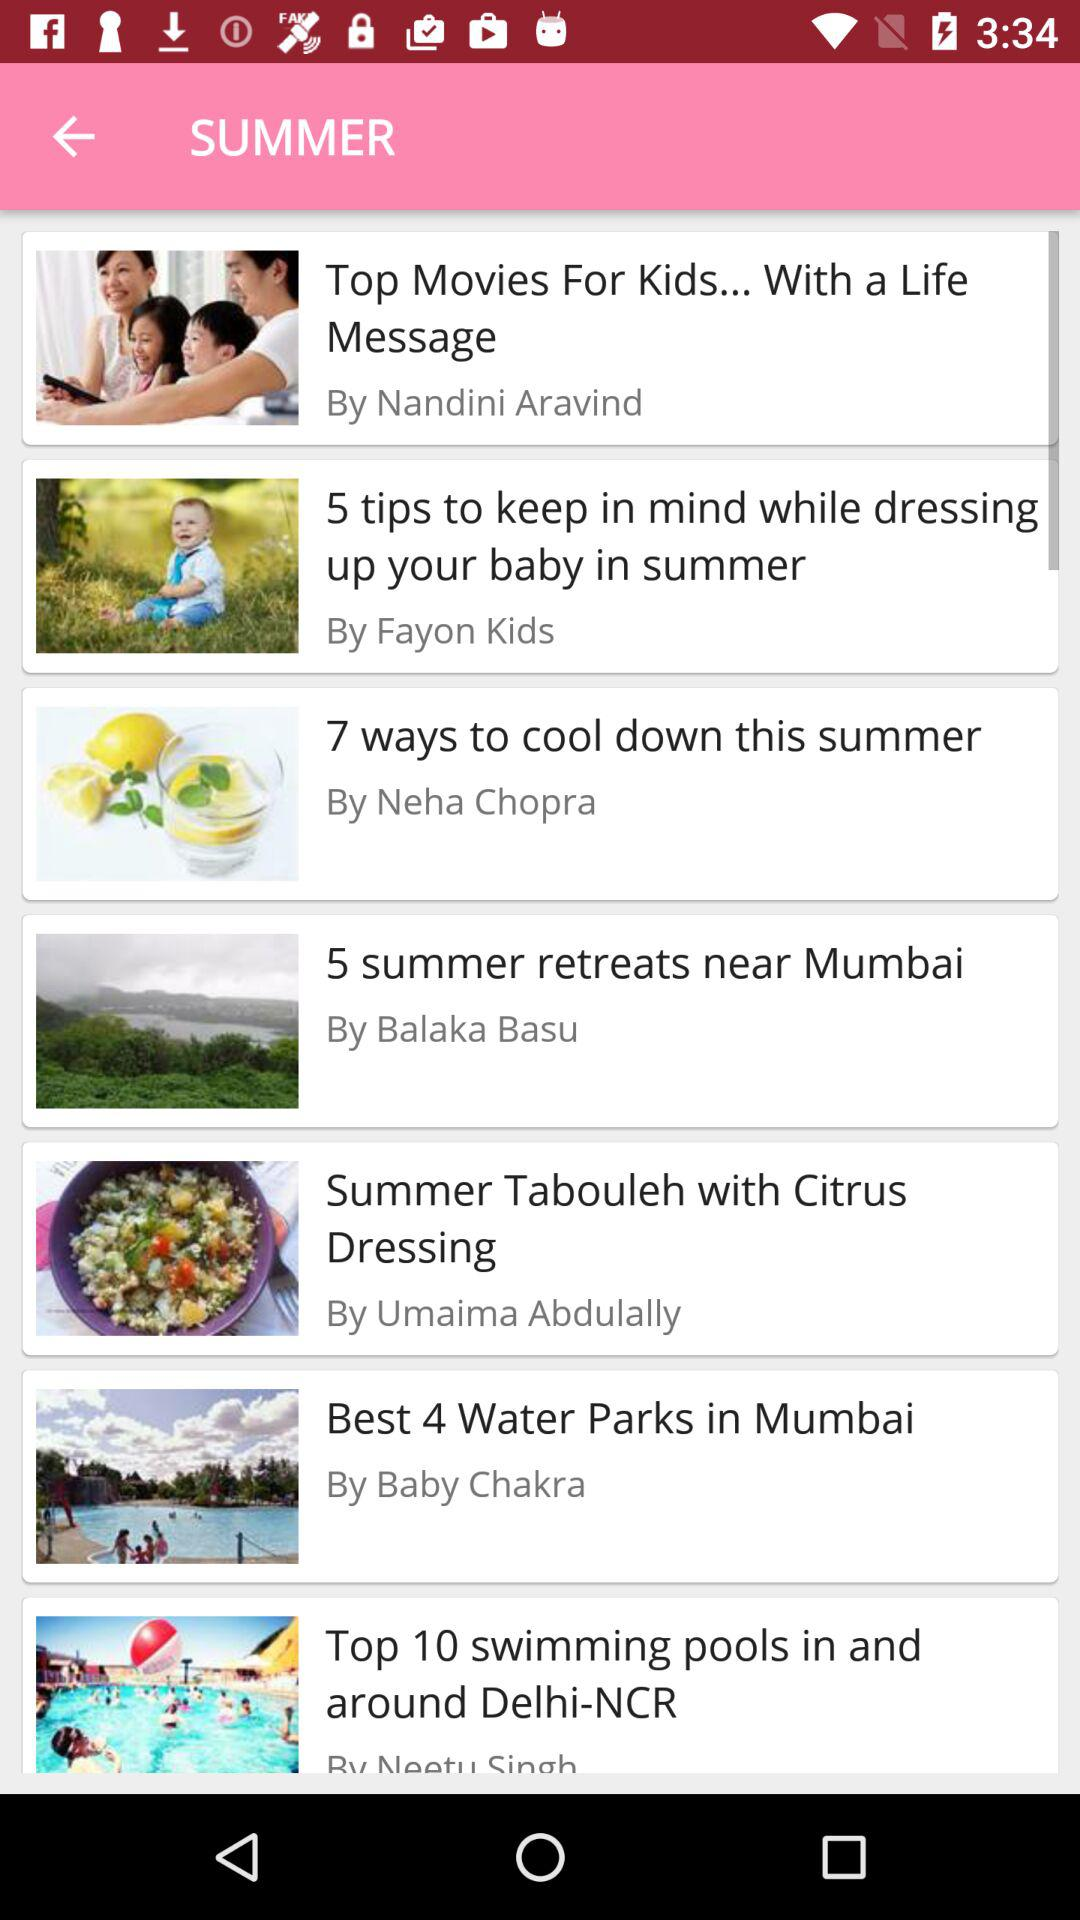What is the number of top swimming pools mentioned in the article title? The number of top swimming pools mentioned in the article title is 10. 